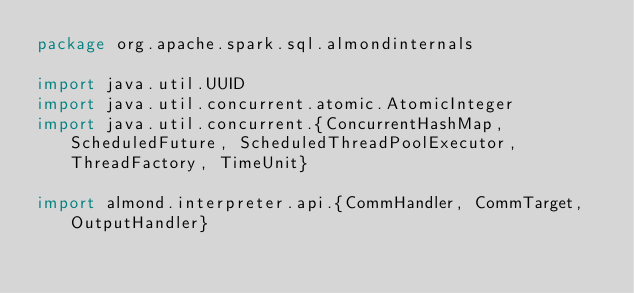Convert code to text. <code><loc_0><loc_0><loc_500><loc_500><_Scala_>package org.apache.spark.sql.almondinternals

import java.util.UUID
import java.util.concurrent.atomic.AtomicInteger
import java.util.concurrent.{ConcurrentHashMap, ScheduledFuture, ScheduledThreadPoolExecutor, ThreadFactory, TimeUnit}

import almond.interpreter.api.{CommHandler, CommTarget, OutputHandler}</code> 